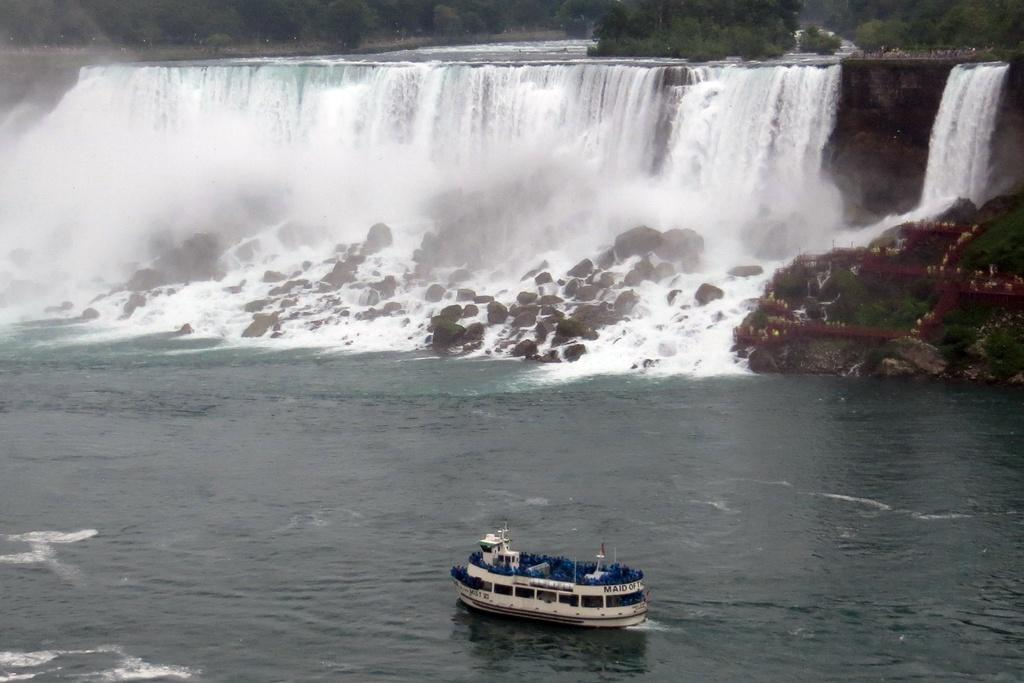What is the main subject of the image? The main subject of the image is a boat. Where is the boat located? The boat is on a river. What can be seen in the background of the image? There is a waterfall and trees in the background of the image. What type of hat is the boat wearing in the image? The boat is not wearing a hat, as boats do not have the ability to wear hats. 